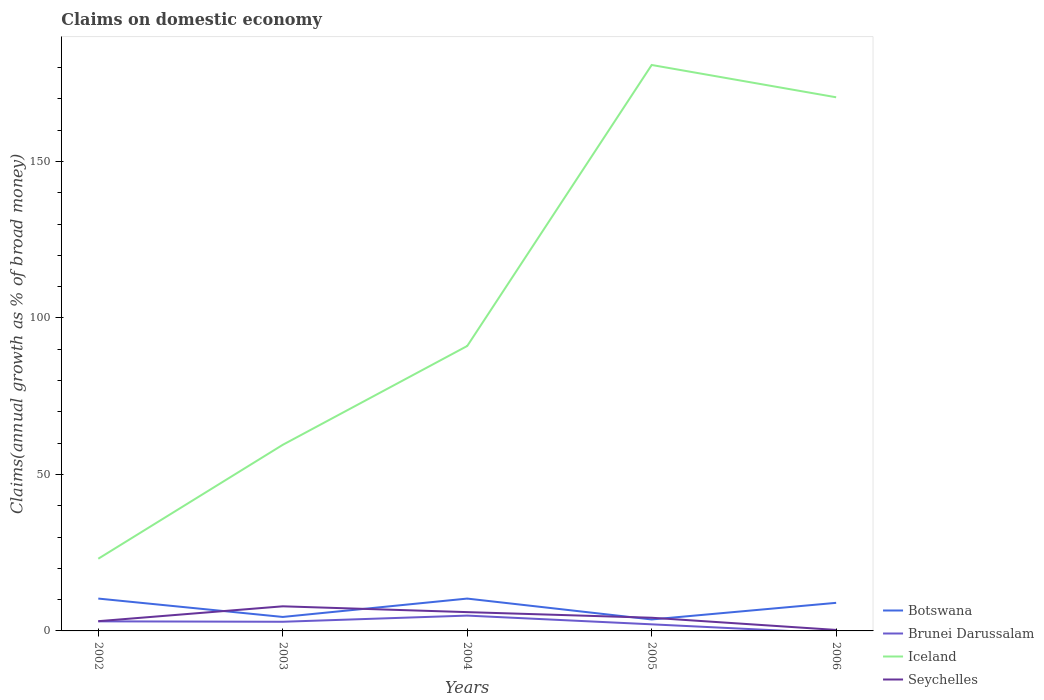Is the number of lines equal to the number of legend labels?
Offer a terse response. No. Across all years, what is the maximum percentage of broad money claimed on domestic economy in Botswana?
Your response must be concise. 3.66. What is the total percentage of broad money claimed on domestic economy in Iceland in the graph?
Your answer should be compact. -157.77. What is the difference between the highest and the second highest percentage of broad money claimed on domestic economy in Seychelles?
Provide a succinct answer. 7.55. How many years are there in the graph?
Offer a very short reply. 5. What is the difference between two consecutive major ticks on the Y-axis?
Offer a very short reply. 50. Are the values on the major ticks of Y-axis written in scientific E-notation?
Your answer should be very brief. No. How many legend labels are there?
Your response must be concise. 4. What is the title of the graph?
Ensure brevity in your answer.  Claims on domestic economy. Does "Netherlands" appear as one of the legend labels in the graph?
Ensure brevity in your answer.  No. What is the label or title of the X-axis?
Provide a short and direct response. Years. What is the label or title of the Y-axis?
Offer a terse response. Claims(annual growth as % of broad money). What is the Claims(annual growth as % of broad money) in Botswana in 2002?
Provide a succinct answer. 10.34. What is the Claims(annual growth as % of broad money) of Brunei Darussalam in 2002?
Provide a short and direct response. 3.06. What is the Claims(annual growth as % of broad money) of Iceland in 2002?
Give a very brief answer. 23.07. What is the Claims(annual growth as % of broad money) in Seychelles in 2002?
Offer a terse response. 3.11. What is the Claims(annual growth as % of broad money) in Botswana in 2003?
Keep it short and to the point. 4.47. What is the Claims(annual growth as % of broad money) of Brunei Darussalam in 2003?
Keep it short and to the point. 2.92. What is the Claims(annual growth as % of broad money) in Iceland in 2003?
Keep it short and to the point. 59.47. What is the Claims(annual growth as % of broad money) in Seychelles in 2003?
Your answer should be compact. 7.86. What is the Claims(annual growth as % of broad money) in Botswana in 2004?
Provide a short and direct response. 10.33. What is the Claims(annual growth as % of broad money) in Brunei Darussalam in 2004?
Ensure brevity in your answer.  4.9. What is the Claims(annual growth as % of broad money) of Iceland in 2004?
Your response must be concise. 91.04. What is the Claims(annual growth as % of broad money) in Seychelles in 2004?
Provide a short and direct response. 6.01. What is the Claims(annual growth as % of broad money) of Botswana in 2005?
Keep it short and to the point. 3.66. What is the Claims(annual growth as % of broad money) in Brunei Darussalam in 2005?
Keep it short and to the point. 2.11. What is the Claims(annual growth as % of broad money) of Iceland in 2005?
Offer a very short reply. 180.84. What is the Claims(annual growth as % of broad money) in Seychelles in 2005?
Your response must be concise. 4.21. What is the Claims(annual growth as % of broad money) in Botswana in 2006?
Your answer should be compact. 8.97. What is the Claims(annual growth as % of broad money) in Brunei Darussalam in 2006?
Keep it short and to the point. 0. What is the Claims(annual growth as % of broad money) of Iceland in 2006?
Your answer should be very brief. 170.52. What is the Claims(annual growth as % of broad money) in Seychelles in 2006?
Your answer should be compact. 0.31. Across all years, what is the maximum Claims(annual growth as % of broad money) in Botswana?
Keep it short and to the point. 10.34. Across all years, what is the maximum Claims(annual growth as % of broad money) of Brunei Darussalam?
Give a very brief answer. 4.9. Across all years, what is the maximum Claims(annual growth as % of broad money) in Iceland?
Your answer should be very brief. 180.84. Across all years, what is the maximum Claims(annual growth as % of broad money) of Seychelles?
Offer a very short reply. 7.86. Across all years, what is the minimum Claims(annual growth as % of broad money) in Botswana?
Your response must be concise. 3.66. Across all years, what is the minimum Claims(annual growth as % of broad money) of Brunei Darussalam?
Provide a succinct answer. 0. Across all years, what is the minimum Claims(annual growth as % of broad money) of Iceland?
Ensure brevity in your answer.  23.07. Across all years, what is the minimum Claims(annual growth as % of broad money) of Seychelles?
Offer a very short reply. 0.31. What is the total Claims(annual growth as % of broad money) of Botswana in the graph?
Ensure brevity in your answer.  37.77. What is the total Claims(annual growth as % of broad money) in Brunei Darussalam in the graph?
Offer a terse response. 12.99. What is the total Claims(annual growth as % of broad money) of Iceland in the graph?
Your answer should be compact. 524.94. What is the total Claims(annual growth as % of broad money) in Seychelles in the graph?
Provide a short and direct response. 21.5. What is the difference between the Claims(annual growth as % of broad money) in Botswana in 2002 and that in 2003?
Give a very brief answer. 5.87. What is the difference between the Claims(annual growth as % of broad money) of Brunei Darussalam in 2002 and that in 2003?
Offer a very short reply. 0.14. What is the difference between the Claims(annual growth as % of broad money) in Iceland in 2002 and that in 2003?
Your answer should be compact. -36.39. What is the difference between the Claims(annual growth as % of broad money) in Seychelles in 2002 and that in 2003?
Offer a terse response. -4.75. What is the difference between the Claims(annual growth as % of broad money) in Botswana in 2002 and that in 2004?
Your answer should be compact. 0. What is the difference between the Claims(annual growth as % of broad money) of Brunei Darussalam in 2002 and that in 2004?
Offer a very short reply. -1.84. What is the difference between the Claims(annual growth as % of broad money) of Iceland in 2002 and that in 2004?
Provide a short and direct response. -67.97. What is the difference between the Claims(annual growth as % of broad money) of Seychelles in 2002 and that in 2004?
Provide a short and direct response. -2.9. What is the difference between the Claims(annual growth as % of broad money) in Botswana in 2002 and that in 2005?
Your answer should be compact. 6.68. What is the difference between the Claims(annual growth as % of broad money) in Brunei Darussalam in 2002 and that in 2005?
Make the answer very short. 0.96. What is the difference between the Claims(annual growth as % of broad money) in Iceland in 2002 and that in 2005?
Provide a short and direct response. -157.77. What is the difference between the Claims(annual growth as % of broad money) of Seychelles in 2002 and that in 2005?
Ensure brevity in your answer.  -1.1. What is the difference between the Claims(annual growth as % of broad money) of Botswana in 2002 and that in 2006?
Provide a short and direct response. 1.36. What is the difference between the Claims(annual growth as % of broad money) in Iceland in 2002 and that in 2006?
Make the answer very short. -147.45. What is the difference between the Claims(annual growth as % of broad money) of Seychelles in 2002 and that in 2006?
Your response must be concise. 2.8. What is the difference between the Claims(annual growth as % of broad money) of Botswana in 2003 and that in 2004?
Keep it short and to the point. -5.87. What is the difference between the Claims(annual growth as % of broad money) in Brunei Darussalam in 2003 and that in 2004?
Your answer should be very brief. -1.98. What is the difference between the Claims(annual growth as % of broad money) in Iceland in 2003 and that in 2004?
Offer a terse response. -31.58. What is the difference between the Claims(annual growth as % of broad money) of Seychelles in 2003 and that in 2004?
Your answer should be very brief. 1.86. What is the difference between the Claims(annual growth as % of broad money) in Botswana in 2003 and that in 2005?
Provide a succinct answer. 0.81. What is the difference between the Claims(annual growth as % of broad money) in Brunei Darussalam in 2003 and that in 2005?
Make the answer very short. 0.82. What is the difference between the Claims(annual growth as % of broad money) of Iceland in 2003 and that in 2005?
Offer a terse response. -121.37. What is the difference between the Claims(annual growth as % of broad money) in Seychelles in 2003 and that in 2005?
Keep it short and to the point. 3.65. What is the difference between the Claims(annual growth as % of broad money) in Botswana in 2003 and that in 2006?
Your answer should be compact. -4.51. What is the difference between the Claims(annual growth as % of broad money) in Iceland in 2003 and that in 2006?
Offer a terse response. -111.05. What is the difference between the Claims(annual growth as % of broad money) in Seychelles in 2003 and that in 2006?
Give a very brief answer. 7.55. What is the difference between the Claims(annual growth as % of broad money) in Botswana in 2004 and that in 2005?
Give a very brief answer. 6.67. What is the difference between the Claims(annual growth as % of broad money) in Brunei Darussalam in 2004 and that in 2005?
Offer a terse response. 2.79. What is the difference between the Claims(annual growth as % of broad money) of Iceland in 2004 and that in 2005?
Keep it short and to the point. -89.79. What is the difference between the Claims(annual growth as % of broad money) of Seychelles in 2004 and that in 2005?
Make the answer very short. 1.8. What is the difference between the Claims(annual growth as % of broad money) in Botswana in 2004 and that in 2006?
Provide a succinct answer. 1.36. What is the difference between the Claims(annual growth as % of broad money) in Iceland in 2004 and that in 2006?
Keep it short and to the point. -79.47. What is the difference between the Claims(annual growth as % of broad money) of Seychelles in 2004 and that in 2006?
Give a very brief answer. 5.69. What is the difference between the Claims(annual growth as % of broad money) in Botswana in 2005 and that in 2006?
Offer a very short reply. -5.31. What is the difference between the Claims(annual growth as % of broad money) of Iceland in 2005 and that in 2006?
Make the answer very short. 10.32. What is the difference between the Claims(annual growth as % of broad money) in Seychelles in 2005 and that in 2006?
Your answer should be compact. 3.9. What is the difference between the Claims(annual growth as % of broad money) in Botswana in 2002 and the Claims(annual growth as % of broad money) in Brunei Darussalam in 2003?
Make the answer very short. 7.41. What is the difference between the Claims(annual growth as % of broad money) in Botswana in 2002 and the Claims(annual growth as % of broad money) in Iceland in 2003?
Your answer should be very brief. -49.13. What is the difference between the Claims(annual growth as % of broad money) in Botswana in 2002 and the Claims(annual growth as % of broad money) in Seychelles in 2003?
Give a very brief answer. 2.47. What is the difference between the Claims(annual growth as % of broad money) in Brunei Darussalam in 2002 and the Claims(annual growth as % of broad money) in Iceland in 2003?
Keep it short and to the point. -56.4. What is the difference between the Claims(annual growth as % of broad money) in Brunei Darussalam in 2002 and the Claims(annual growth as % of broad money) in Seychelles in 2003?
Offer a very short reply. -4.8. What is the difference between the Claims(annual growth as % of broad money) in Iceland in 2002 and the Claims(annual growth as % of broad money) in Seychelles in 2003?
Offer a very short reply. 15.21. What is the difference between the Claims(annual growth as % of broad money) of Botswana in 2002 and the Claims(annual growth as % of broad money) of Brunei Darussalam in 2004?
Your answer should be compact. 5.44. What is the difference between the Claims(annual growth as % of broad money) in Botswana in 2002 and the Claims(annual growth as % of broad money) in Iceland in 2004?
Offer a terse response. -80.71. What is the difference between the Claims(annual growth as % of broad money) in Botswana in 2002 and the Claims(annual growth as % of broad money) in Seychelles in 2004?
Provide a succinct answer. 4.33. What is the difference between the Claims(annual growth as % of broad money) in Brunei Darussalam in 2002 and the Claims(annual growth as % of broad money) in Iceland in 2004?
Ensure brevity in your answer.  -87.98. What is the difference between the Claims(annual growth as % of broad money) of Brunei Darussalam in 2002 and the Claims(annual growth as % of broad money) of Seychelles in 2004?
Keep it short and to the point. -2.94. What is the difference between the Claims(annual growth as % of broad money) in Iceland in 2002 and the Claims(annual growth as % of broad money) in Seychelles in 2004?
Offer a terse response. 17.06. What is the difference between the Claims(annual growth as % of broad money) of Botswana in 2002 and the Claims(annual growth as % of broad money) of Brunei Darussalam in 2005?
Offer a terse response. 8.23. What is the difference between the Claims(annual growth as % of broad money) of Botswana in 2002 and the Claims(annual growth as % of broad money) of Iceland in 2005?
Your response must be concise. -170.5. What is the difference between the Claims(annual growth as % of broad money) in Botswana in 2002 and the Claims(annual growth as % of broad money) in Seychelles in 2005?
Your response must be concise. 6.13. What is the difference between the Claims(annual growth as % of broad money) in Brunei Darussalam in 2002 and the Claims(annual growth as % of broad money) in Iceland in 2005?
Your answer should be very brief. -177.78. What is the difference between the Claims(annual growth as % of broad money) in Brunei Darussalam in 2002 and the Claims(annual growth as % of broad money) in Seychelles in 2005?
Your answer should be very brief. -1.15. What is the difference between the Claims(annual growth as % of broad money) of Iceland in 2002 and the Claims(annual growth as % of broad money) of Seychelles in 2005?
Give a very brief answer. 18.86. What is the difference between the Claims(annual growth as % of broad money) of Botswana in 2002 and the Claims(annual growth as % of broad money) of Iceland in 2006?
Your answer should be compact. -160.18. What is the difference between the Claims(annual growth as % of broad money) of Botswana in 2002 and the Claims(annual growth as % of broad money) of Seychelles in 2006?
Give a very brief answer. 10.02. What is the difference between the Claims(annual growth as % of broad money) in Brunei Darussalam in 2002 and the Claims(annual growth as % of broad money) in Iceland in 2006?
Give a very brief answer. -167.46. What is the difference between the Claims(annual growth as % of broad money) of Brunei Darussalam in 2002 and the Claims(annual growth as % of broad money) of Seychelles in 2006?
Make the answer very short. 2.75. What is the difference between the Claims(annual growth as % of broad money) in Iceland in 2002 and the Claims(annual growth as % of broad money) in Seychelles in 2006?
Keep it short and to the point. 22.76. What is the difference between the Claims(annual growth as % of broad money) in Botswana in 2003 and the Claims(annual growth as % of broad money) in Brunei Darussalam in 2004?
Your response must be concise. -0.43. What is the difference between the Claims(annual growth as % of broad money) in Botswana in 2003 and the Claims(annual growth as % of broad money) in Iceland in 2004?
Your answer should be very brief. -86.58. What is the difference between the Claims(annual growth as % of broad money) of Botswana in 2003 and the Claims(annual growth as % of broad money) of Seychelles in 2004?
Offer a very short reply. -1.54. What is the difference between the Claims(annual growth as % of broad money) of Brunei Darussalam in 2003 and the Claims(annual growth as % of broad money) of Iceland in 2004?
Keep it short and to the point. -88.12. What is the difference between the Claims(annual growth as % of broad money) of Brunei Darussalam in 2003 and the Claims(annual growth as % of broad money) of Seychelles in 2004?
Your answer should be compact. -3.08. What is the difference between the Claims(annual growth as % of broad money) of Iceland in 2003 and the Claims(annual growth as % of broad money) of Seychelles in 2004?
Provide a short and direct response. 53.46. What is the difference between the Claims(annual growth as % of broad money) in Botswana in 2003 and the Claims(annual growth as % of broad money) in Brunei Darussalam in 2005?
Make the answer very short. 2.36. What is the difference between the Claims(annual growth as % of broad money) in Botswana in 2003 and the Claims(annual growth as % of broad money) in Iceland in 2005?
Provide a succinct answer. -176.37. What is the difference between the Claims(annual growth as % of broad money) in Botswana in 2003 and the Claims(annual growth as % of broad money) in Seychelles in 2005?
Offer a very short reply. 0.26. What is the difference between the Claims(annual growth as % of broad money) of Brunei Darussalam in 2003 and the Claims(annual growth as % of broad money) of Iceland in 2005?
Offer a very short reply. -177.91. What is the difference between the Claims(annual growth as % of broad money) of Brunei Darussalam in 2003 and the Claims(annual growth as % of broad money) of Seychelles in 2005?
Offer a terse response. -1.29. What is the difference between the Claims(annual growth as % of broad money) of Iceland in 2003 and the Claims(annual growth as % of broad money) of Seychelles in 2005?
Ensure brevity in your answer.  55.26. What is the difference between the Claims(annual growth as % of broad money) of Botswana in 2003 and the Claims(annual growth as % of broad money) of Iceland in 2006?
Ensure brevity in your answer.  -166.05. What is the difference between the Claims(annual growth as % of broad money) of Botswana in 2003 and the Claims(annual growth as % of broad money) of Seychelles in 2006?
Ensure brevity in your answer.  4.15. What is the difference between the Claims(annual growth as % of broad money) in Brunei Darussalam in 2003 and the Claims(annual growth as % of broad money) in Iceland in 2006?
Provide a short and direct response. -167.59. What is the difference between the Claims(annual growth as % of broad money) in Brunei Darussalam in 2003 and the Claims(annual growth as % of broad money) in Seychelles in 2006?
Give a very brief answer. 2.61. What is the difference between the Claims(annual growth as % of broad money) in Iceland in 2003 and the Claims(annual growth as % of broad money) in Seychelles in 2006?
Offer a very short reply. 59.15. What is the difference between the Claims(annual growth as % of broad money) of Botswana in 2004 and the Claims(annual growth as % of broad money) of Brunei Darussalam in 2005?
Provide a short and direct response. 8.23. What is the difference between the Claims(annual growth as % of broad money) of Botswana in 2004 and the Claims(annual growth as % of broad money) of Iceland in 2005?
Make the answer very short. -170.5. What is the difference between the Claims(annual growth as % of broad money) in Botswana in 2004 and the Claims(annual growth as % of broad money) in Seychelles in 2005?
Your answer should be very brief. 6.13. What is the difference between the Claims(annual growth as % of broad money) in Brunei Darussalam in 2004 and the Claims(annual growth as % of broad money) in Iceland in 2005?
Your response must be concise. -175.94. What is the difference between the Claims(annual growth as % of broad money) in Brunei Darussalam in 2004 and the Claims(annual growth as % of broad money) in Seychelles in 2005?
Make the answer very short. 0.69. What is the difference between the Claims(annual growth as % of broad money) of Iceland in 2004 and the Claims(annual growth as % of broad money) of Seychelles in 2005?
Give a very brief answer. 86.84. What is the difference between the Claims(annual growth as % of broad money) in Botswana in 2004 and the Claims(annual growth as % of broad money) in Iceland in 2006?
Your answer should be very brief. -160.18. What is the difference between the Claims(annual growth as % of broad money) of Botswana in 2004 and the Claims(annual growth as % of broad money) of Seychelles in 2006?
Ensure brevity in your answer.  10.02. What is the difference between the Claims(annual growth as % of broad money) of Brunei Darussalam in 2004 and the Claims(annual growth as % of broad money) of Iceland in 2006?
Offer a very short reply. -165.62. What is the difference between the Claims(annual growth as % of broad money) of Brunei Darussalam in 2004 and the Claims(annual growth as % of broad money) of Seychelles in 2006?
Provide a short and direct response. 4.59. What is the difference between the Claims(annual growth as % of broad money) in Iceland in 2004 and the Claims(annual growth as % of broad money) in Seychelles in 2006?
Keep it short and to the point. 90.73. What is the difference between the Claims(annual growth as % of broad money) in Botswana in 2005 and the Claims(annual growth as % of broad money) in Iceland in 2006?
Make the answer very short. -166.86. What is the difference between the Claims(annual growth as % of broad money) of Botswana in 2005 and the Claims(annual growth as % of broad money) of Seychelles in 2006?
Offer a terse response. 3.35. What is the difference between the Claims(annual growth as % of broad money) in Brunei Darussalam in 2005 and the Claims(annual growth as % of broad money) in Iceland in 2006?
Your answer should be very brief. -168.41. What is the difference between the Claims(annual growth as % of broad money) of Brunei Darussalam in 2005 and the Claims(annual growth as % of broad money) of Seychelles in 2006?
Offer a terse response. 1.79. What is the difference between the Claims(annual growth as % of broad money) in Iceland in 2005 and the Claims(annual growth as % of broad money) in Seychelles in 2006?
Offer a terse response. 180.52. What is the average Claims(annual growth as % of broad money) in Botswana per year?
Your answer should be very brief. 7.55. What is the average Claims(annual growth as % of broad money) in Brunei Darussalam per year?
Give a very brief answer. 2.6. What is the average Claims(annual growth as % of broad money) of Iceland per year?
Provide a short and direct response. 104.99. What is the average Claims(annual growth as % of broad money) of Seychelles per year?
Ensure brevity in your answer.  4.3. In the year 2002, what is the difference between the Claims(annual growth as % of broad money) in Botswana and Claims(annual growth as % of broad money) in Brunei Darussalam?
Give a very brief answer. 7.27. In the year 2002, what is the difference between the Claims(annual growth as % of broad money) of Botswana and Claims(annual growth as % of broad money) of Iceland?
Ensure brevity in your answer.  -12.73. In the year 2002, what is the difference between the Claims(annual growth as % of broad money) in Botswana and Claims(annual growth as % of broad money) in Seychelles?
Make the answer very short. 7.23. In the year 2002, what is the difference between the Claims(annual growth as % of broad money) of Brunei Darussalam and Claims(annual growth as % of broad money) of Iceland?
Provide a short and direct response. -20.01. In the year 2002, what is the difference between the Claims(annual growth as % of broad money) of Brunei Darussalam and Claims(annual growth as % of broad money) of Seychelles?
Your response must be concise. -0.05. In the year 2002, what is the difference between the Claims(annual growth as % of broad money) of Iceland and Claims(annual growth as % of broad money) of Seychelles?
Your response must be concise. 19.96. In the year 2003, what is the difference between the Claims(annual growth as % of broad money) of Botswana and Claims(annual growth as % of broad money) of Brunei Darussalam?
Keep it short and to the point. 1.54. In the year 2003, what is the difference between the Claims(annual growth as % of broad money) of Botswana and Claims(annual growth as % of broad money) of Iceland?
Your answer should be very brief. -55. In the year 2003, what is the difference between the Claims(annual growth as % of broad money) of Botswana and Claims(annual growth as % of broad money) of Seychelles?
Ensure brevity in your answer.  -3.4. In the year 2003, what is the difference between the Claims(annual growth as % of broad money) in Brunei Darussalam and Claims(annual growth as % of broad money) in Iceland?
Give a very brief answer. -56.54. In the year 2003, what is the difference between the Claims(annual growth as % of broad money) of Brunei Darussalam and Claims(annual growth as % of broad money) of Seychelles?
Give a very brief answer. -4.94. In the year 2003, what is the difference between the Claims(annual growth as % of broad money) in Iceland and Claims(annual growth as % of broad money) in Seychelles?
Make the answer very short. 51.6. In the year 2004, what is the difference between the Claims(annual growth as % of broad money) in Botswana and Claims(annual growth as % of broad money) in Brunei Darussalam?
Your response must be concise. 5.43. In the year 2004, what is the difference between the Claims(annual growth as % of broad money) in Botswana and Claims(annual growth as % of broad money) in Iceland?
Your response must be concise. -80.71. In the year 2004, what is the difference between the Claims(annual growth as % of broad money) of Botswana and Claims(annual growth as % of broad money) of Seychelles?
Offer a very short reply. 4.33. In the year 2004, what is the difference between the Claims(annual growth as % of broad money) of Brunei Darussalam and Claims(annual growth as % of broad money) of Iceland?
Make the answer very short. -86.15. In the year 2004, what is the difference between the Claims(annual growth as % of broad money) of Brunei Darussalam and Claims(annual growth as % of broad money) of Seychelles?
Ensure brevity in your answer.  -1.11. In the year 2004, what is the difference between the Claims(annual growth as % of broad money) in Iceland and Claims(annual growth as % of broad money) in Seychelles?
Keep it short and to the point. 85.04. In the year 2005, what is the difference between the Claims(annual growth as % of broad money) of Botswana and Claims(annual growth as % of broad money) of Brunei Darussalam?
Your answer should be very brief. 1.55. In the year 2005, what is the difference between the Claims(annual growth as % of broad money) in Botswana and Claims(annual growth as % of broad money) in Iceland?
Provide a short and direct response. -177.18. In the year 2005, what is the difference between the Claims(annual growth as % of broad money) in Botswana and Claims(annual growth as % of broad money) in Seychelles?
Provide a succinct answer. -0.55. In the year 2005, what is the difference between the Claims(annual growth as % of broad money) in Brunei Darussalam and Claims(annual growth as % of broad money) in Iceland?
Offer a very short reply. -178.73. In the year 2005, what is the difference between the Claims(annual growth as % of broad money) in Brunei Darussalam and Claims(annual growth as % of broad money) in Seychelles?
Give a very brief answer. -2.1. In the year 2005, what is the difference between the Claims(annual growth as % of broad money) of Iceland and Claims(annual growth as % of broad money) of Seychelles?
Your response must be concise. 176.63. In the year 2006, what is the difference between the Claims(annual growth as % of broad money) in Botswana and Claims(annual growth as % of broad money) in Iceland?
Provide a succinct answer. -161.54. In the year 2006, what is the difference between the Claims(annual growth as % of broad money) in Botswana and Claims(annual growth as % of broad money) in Seychelles?
Keep it short and to the point. 8.66. In the year 2006, what is the difference between the Claims(annual growth as % of broad money) in Iceland and Claims(annual growth as % of broad money) in Seychelles?
Provide a succinct answer. 170.2. What is the ratio of the Claims(annual growth as % of broad money) in Botswana in 2002 to that in 2003?
Offer a terse response. 2.31. What is the ratio of the Claims(annual growth as % of broad money) in Brunei Darussalam in 2002 to that in 2003?
Ensure brevity in your answer.  1.05. What is the ratio of the Claims(annual growth as % of broad money) in Iceland in 2002 to that in 2003?
Provide a succinct answer. 0.39. What is the ratio of the Claims(annual growth as % of broad money) of Seychelles in 2002 to that in 2003?
Your answer should be very brief. 0.4. What is the ratio of the Claims(annual growth as % of broad money) in Iceland in 2002 to that in 2004?
Your answer should be very brief. 0.25. What is the ratio of the Claims(annual growth as % of broad money) of Seychelles in 2002 to that in 2004?
Your response must be concise. 0.52. What is the ratio of the Claims(annual growth as % of broad money) of Botswana in 2002 to that in 2005?
Offer a terse response. 2.82. What is the ratio of the Claims(annual growth as % of broad money) of Brunei Darussalam in 2002 to that in 2005?
Offer a very short reply. 1.45. What is the ratio of the Claims(annual growth as % of broad money) of Iceland in 2002 to that in 2005?
Your answer should be very brief. 0.13. What is the ratio of the Claims(annual growth as % of broad money) in Seychelles in 2002 to that in 2005?
Your response must be concise. 0.74. What is the ratio of the Claims(annual growth as % of broad money) of Botswana in 2002 to that in 2006?
Your answer should be compact. 1.15. What is the ratio of the Claims(annual growth as % of broad money) in Iceland in 2002 to that in 2006?
Provide a short and direct response. 0.14. What is the ratio of the Claims(annual growth as % of broad money) of Seychelles in 2002 to that in 2006?
Provide a succinct answer. 9.92. What is the ratio of the Claims(annual growth as % of broad money) in Botswana in 2003 to that in 2004?
Your answer should be compact. 0.43. What is the ratio of the Claims(annual growth as % of broad money) in Brunei Darussalam in 2003 to that in 2004?
Provide a succinct answer. 0.6. What is the ratio of the Claims(annual growth as % of broad money) of Iceland in 2003 to that in 2004?
Give a very brief answer. 0.65. What is the ratio of the Claims(annual growth as % of broad money) in Seychelles in 2003 to that in 2004?
Give a very brief answer. 1.31. What is the ratio of the Claims(annual growth as % of broad money) of Botswana in 2003 to that in 2005?
Your answer should be very brief. 1.22. What is the ratio of the Claims(annual growth as % of broad money) of Brunei Darussalam in 2003 to that in 2005?
Provide a short and direct response. 1.39. What is the ratio of the Claims(annual growth as % of broad money) of Iceland in 2003 to that in 2005?
Offer a terse response. 0.33. What is the ratio of the Claims(annual growth as % of broad money) in Seychelles in 2003 to that in 2005?
Provide a succinct answer. 1.87. What is the ratio of the Claims(annual growth as % of broad money) of Botswana in 2003 to that in 2006?
Your answer should be very brief. 0.5. What is the ratio of the Claims(annual growth as % of broad money) of Iceland in 2003 to that in 2006?
Give a very brief answer. 0.35. What is the ratio of the Claims(annual growth as % of broad money) of Seychelles in 2003 to that in 2006?
Provide a succinct answer. 25.08. What is the ratio of the Claims(annual growth as % of broad money) of Botswana in 2004 to that in 2005?
Provide a short and direct response. 2.82. What is the ratio of the Claims(annual growth as % of broad money) of Brunei Darussalam in 2004 to that in 2005?
Give a very brief answer. 2.33. What is the ratio of the Claims(annual growth as % of broad money) in Iceland in 2004 to that in 2005?
Your answer should be compact. 0.5. What is the ratio of the Claims(annual growth as % of broad money) of Seychelles in 2004 to that in 2005?
Ensure brevity in your answer.  1.43. What is the ratio of the Claims(annual growth as % of broad money) in Botswana in 2004 to that in 2006?
Make the answer very short. 1.15. What is the ratio of the Claims(annual growth as % of broad money) of Iceland in 2004 to that in 2006?
Offer a very short reply. 0.53. What is the ratio of the Claims(annual growth as % of broad money) of Seychelles in 2004 to that in 2006?
Provide a short and direct response. 19.16. What is the ratio of the Claims(annual growth as % of broad money) in Botswana in 2005 to that in 2006?
Offer a very short reply. 0.41. What is the ratio of the Claims(annual growth as % of broad money) in Iceland in 2005 to that in 2006?
Give a very brief answer. 1.06. What is the ratio of the Claims(annual growth as % of broad money) in Seychelles in 2005 to that in 2006?
Your answer should be very brief. 13.43. What is the difference between the highest and the second highest Claims(annual growth as % of broad money) of Botswana?
Your response must be concise. 0. What is the difference between the highest and the second highest Claims(annual growth as % of broad money) in Brunei Darussalam?
Give a very brief answer. 1.84. What is the difference between the highest and the second highest Claims(annual growth as % of broad money) in Iceland?
Provide a short and direct response. 10.32. What is the difference between the highest and the second highest Claims(annual growth as % of broad money) of Seychelles?
Provide a succinct answer. 1.86. What is the difference between the highest and the lowest Claims(annual growth as % of broad money) in Botswana?
Offer a very short reply. 6.68. What is the difference between the highest and the lowest Claims(annual growth as % of broad money) of Brunei Darussalam?
Your response must be concise. 4.9. What is the difference between the highest and the lowest Claims(annual growth as % of broad money) in Iceland?
Keep it short and to the point. 157.77. What is the difference between the highest and the lowest Claims(annual growth as % of broad money) of Seychelles?
Ensure brevity in your answer.  7.55. 